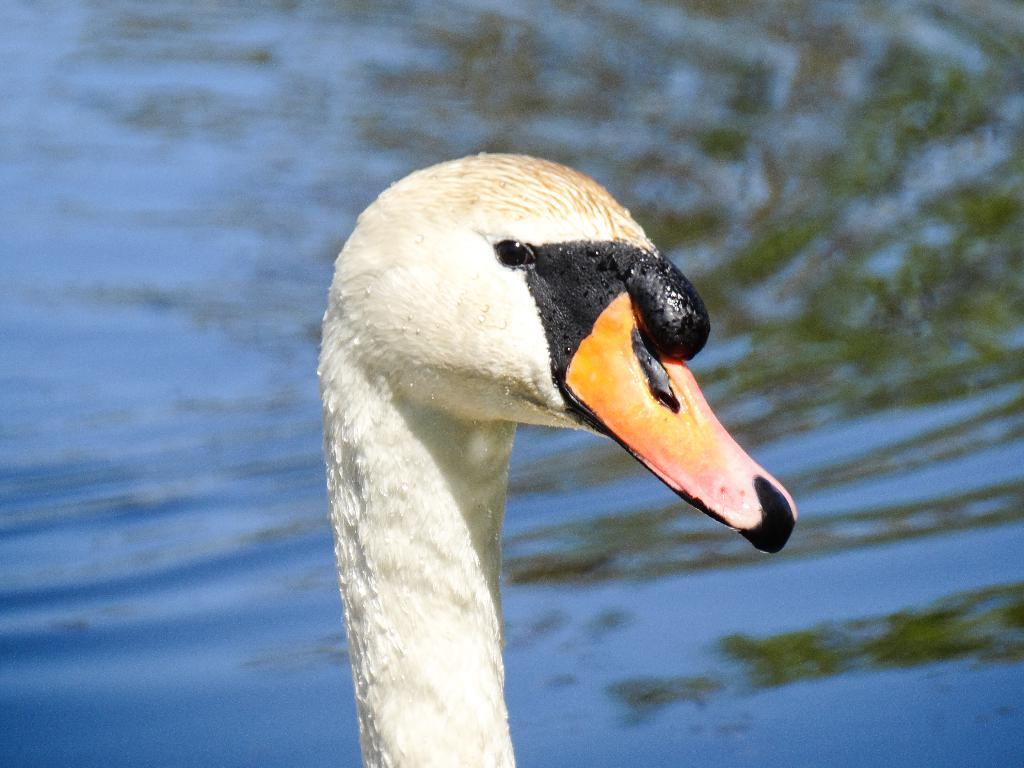What can be seen in the background of the image? There is water visible in the background of the image. What type of animal is partially visible in the image? A partial part of a swan is present in the image. How many boys are present in the image? There is no boy present in the image; it features a partial part of a swan and water in the background. What message of peace can be seen in the image? There is no message of peace present in the image; it features a partial part of a swan and water in the background. 